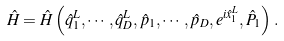<formula> <loc_0><loc_0><loc_500><loc_500>\hat { H } = \hat { H } \left ( \hat { q } ^ { L } _ { 1 } , \cdots , \hat { q } ^ { L } _ { D } , \hat { p } _ { 1 } , \cdots , \hat { p } _ { D } , e ^ { i \hat { x } _ { 1 } ^ { L } } , \hat { P } _ { 1 } \right ) \, .</formula> 